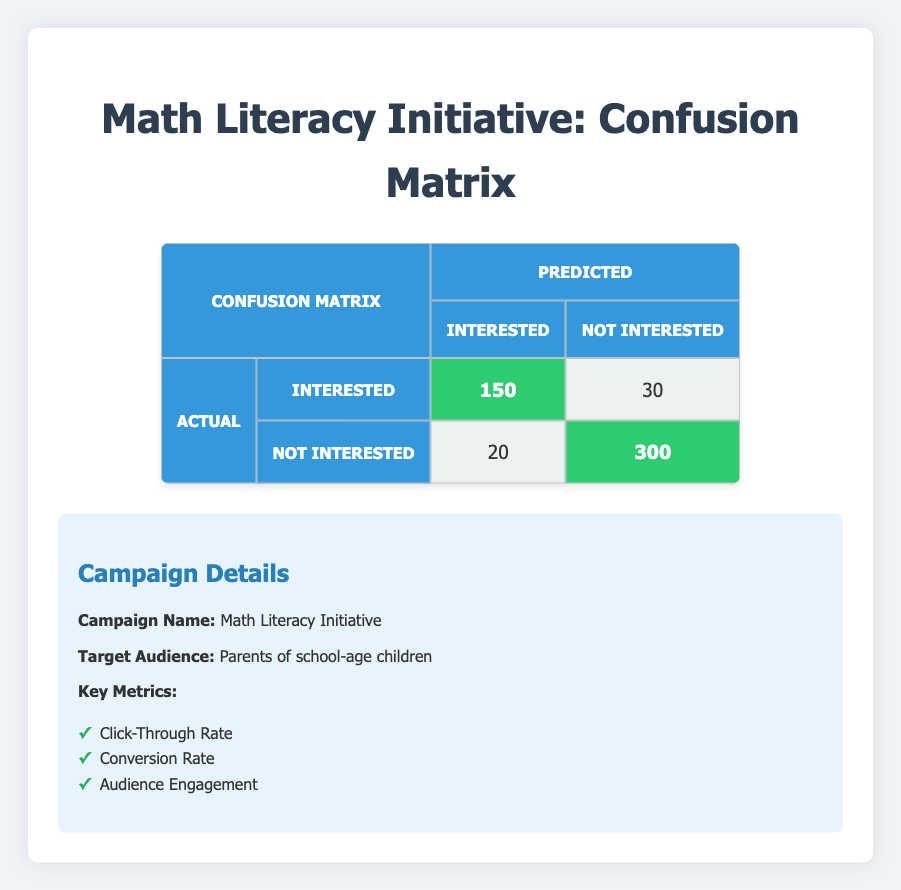What is the total number of people predicted to be interested in the campaign? To find this, we need to sum the values in the first column for both predicted "Interested" categories: 150 (actual Interested, predicted Interested) + 20 (actual Not Interested, predicted Interested) = 170.
Answer: 170 How many people were actually not interested in the marketing campaign? We can find this by looking at the "Not Interested" row under the "Actual" column. The total for the actual "Not Interested" category is the sum of 20 (predicted Interested) and 300 (predicted Not Interested) = 320.
Answer: 320 What is the count of people who were wrongfully predicted as interested? This corresponds to the entry in the confusion matrix where actual "Not Interested" is predicted as "Interested," which is 20.
Answer: 20 Did more people express actual interest in the campaign than those who expressed no interest? To determine this, we compare the totals of actual "Interested" (150 + 30 = 180) with actual "Not Interested" (20 + 300 = 320). Since 180 is less than 320, the answer is no.
Answer: No What is the accuracy of the predictions made by the marketing campaign? Accuracy is calculated as the sum of true positives and true negatives divided by the total number of predictions. We add the true positives (150) and true negatives (300), giving us 450, then divide by the total cases (150 + 30 + 20 + 300 = 500). The calculation is 450/500 = 0.9 or 90%.
Answer: 90% How many people were predicted to not be interested in the campaign? To find this, we need to sum the values in the second column under both predicted "Not Interested" categories: 30 (actual Interested, predicted Not Interested) + 300 (actual Not Interested, predicted Not Interested) = 330.
Answer: 330 What percentage of people who were predicted to be not interested were actually not interested? We take the number of true negatives (300) and divide it by the total predicted not interested (30 + 300 = 330), then multiply by 100 to get the percentage: (300/330) * 100 ≈ 90.91%.
Answer: 90.91% What is the total number of people in the marketing campaign? The total is found by summing all entries in the confusion matrix: 150 + 30 + 20 + 300 = 500.
Answer: 500 